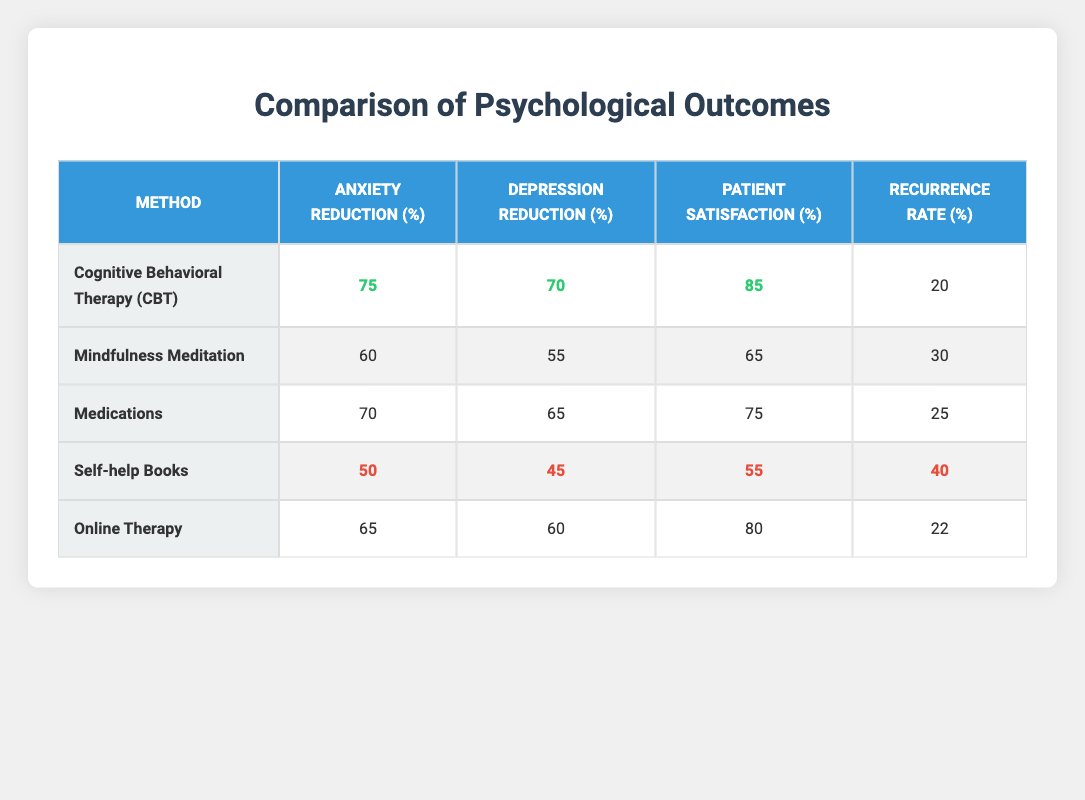What is the anxiety reduction percentage for Cognitive Behavioral Therapy? The table shows that the anxiety reduction for Cognitive Behavioral Therapy is listed in the respective cell under the "Anxiety Reduction (%)" column for that method. This value is 75.
Answer: 75 What is the patient satisfaction percentage for Self-help Books? According to the "Patient Satisfaction (%)" column, the corresponding value for Self-help Books is provided. This value is 55.
Answer: 55 Which method has the highest depression reduction percentage? By examining the "Depression Reduction (%)" column, we can identify that the maximum value is 70, which corresponds to Cognitive Behavioral Therapy.
Answer: Cognitive Behavioral Therapy What is the recurrence rate for Mindfulness Meditation compared to Online Therapy? The recurrence rates can be found in the "Recurrence Rate (%)" column. Mindfulness Meditation has a recurrence rate of 30, while Online Therapy has a rate of 22, implying that Online Therapy has a lower recurrence rate than Mindfulness Meditation.
Answer: Online Therapy has a lower recurrence rate What is the average anxiety reduction percentage across all methods? To find the average, we sum the anxiety reduction percentages from each method: 75 + 60 + 70 + 50 + 65 = 320. Then, we divide by the number of methods, which is 5. 320 / 5 = 64.
Answer: 64 Is it true that both Medications and Cognitive Behavioral Therapy have patient satisfaction rates above 70%? We need to look for the patient satisfaction values in their respective rows. According to the table, Medications has a patient satisfaction of 75, while CBT has a satisfaction of 85, both of which are above 70%. Thus, the statement is true.
Answer: Yes What is the difference in anxiety reduction percentage between the best and worst-performing methods? We determine that the best method for anxiety reduction is Cognitive Behavioral Therapy at 75%, and the worst is Self-help Books at 50%. We calculate the difference: 75 - 50 = 25.
Answer: 25 Which self-help method shows the lowest patient satisfaction rate? To ascertain this, we compare the patient satisfaction values in the "Patient Satisfaction (%)" column, identifying Self-help Books at 55% as the lowest among the methods listed.
Answer: Self-help Books Which therapy method has both the highest patient satisfaction and lowest recurrence rate? We examine the table for the highest "Patient Satisfaction (%)" which is 85 for Cognitive Behavioral Therapy and check the "Recurrence Rate (%)" column where CBT shows a recurrence rate of 20. This indicates that CBT meets both criteria.
Answer: Cognitive Behavioral Therapy 